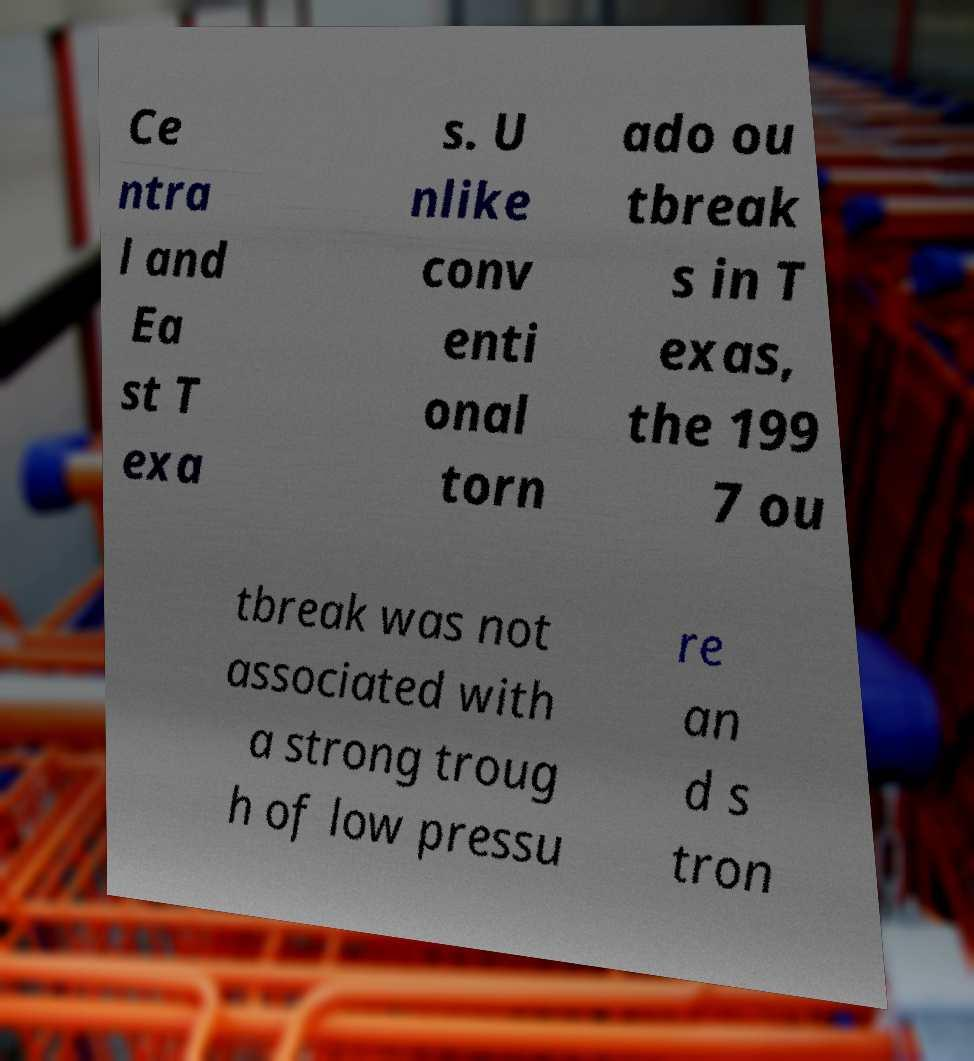Could you assist in decoding the text presented in this image and type it out clearly? Ce ntra l and Ea st T exa s. U nlike conv enti onal torn ado ou tbreak s in T exas, the 199 7 ou tbreak was not associated with a strong troug h of low pressu re an d s tron 